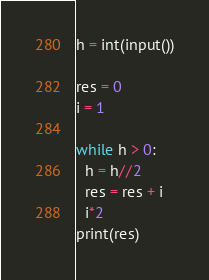<code> <loc_0><loc_0><loc_500><loc_500><_Python_>h = int(input())

res = 0
i = 1

while h > 0:
  h = h//2
  res = res + i
  i*2
print(res)</code> 